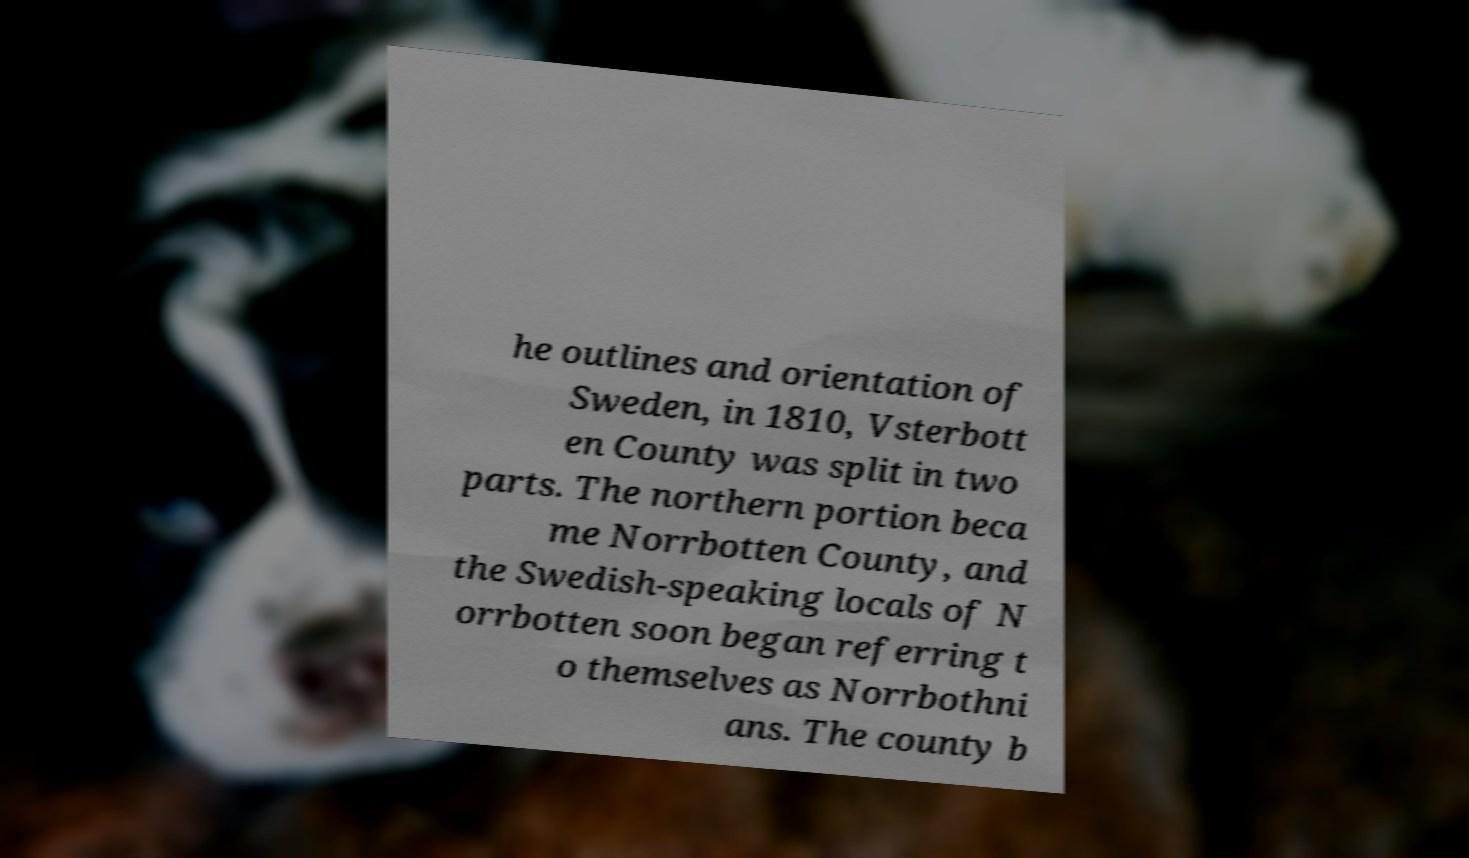There's text embedded in this image that I need extracted. Can you transcribe it verbatim? he outlines and orientation of Sweden, in 1810, Vsterbott en County was split in two parts. The northern portion beca me Norrbotten County, and the Swedish-speaking locals of N orrbotten soon began referring t o themselves as Norrbothni ans. The county b 